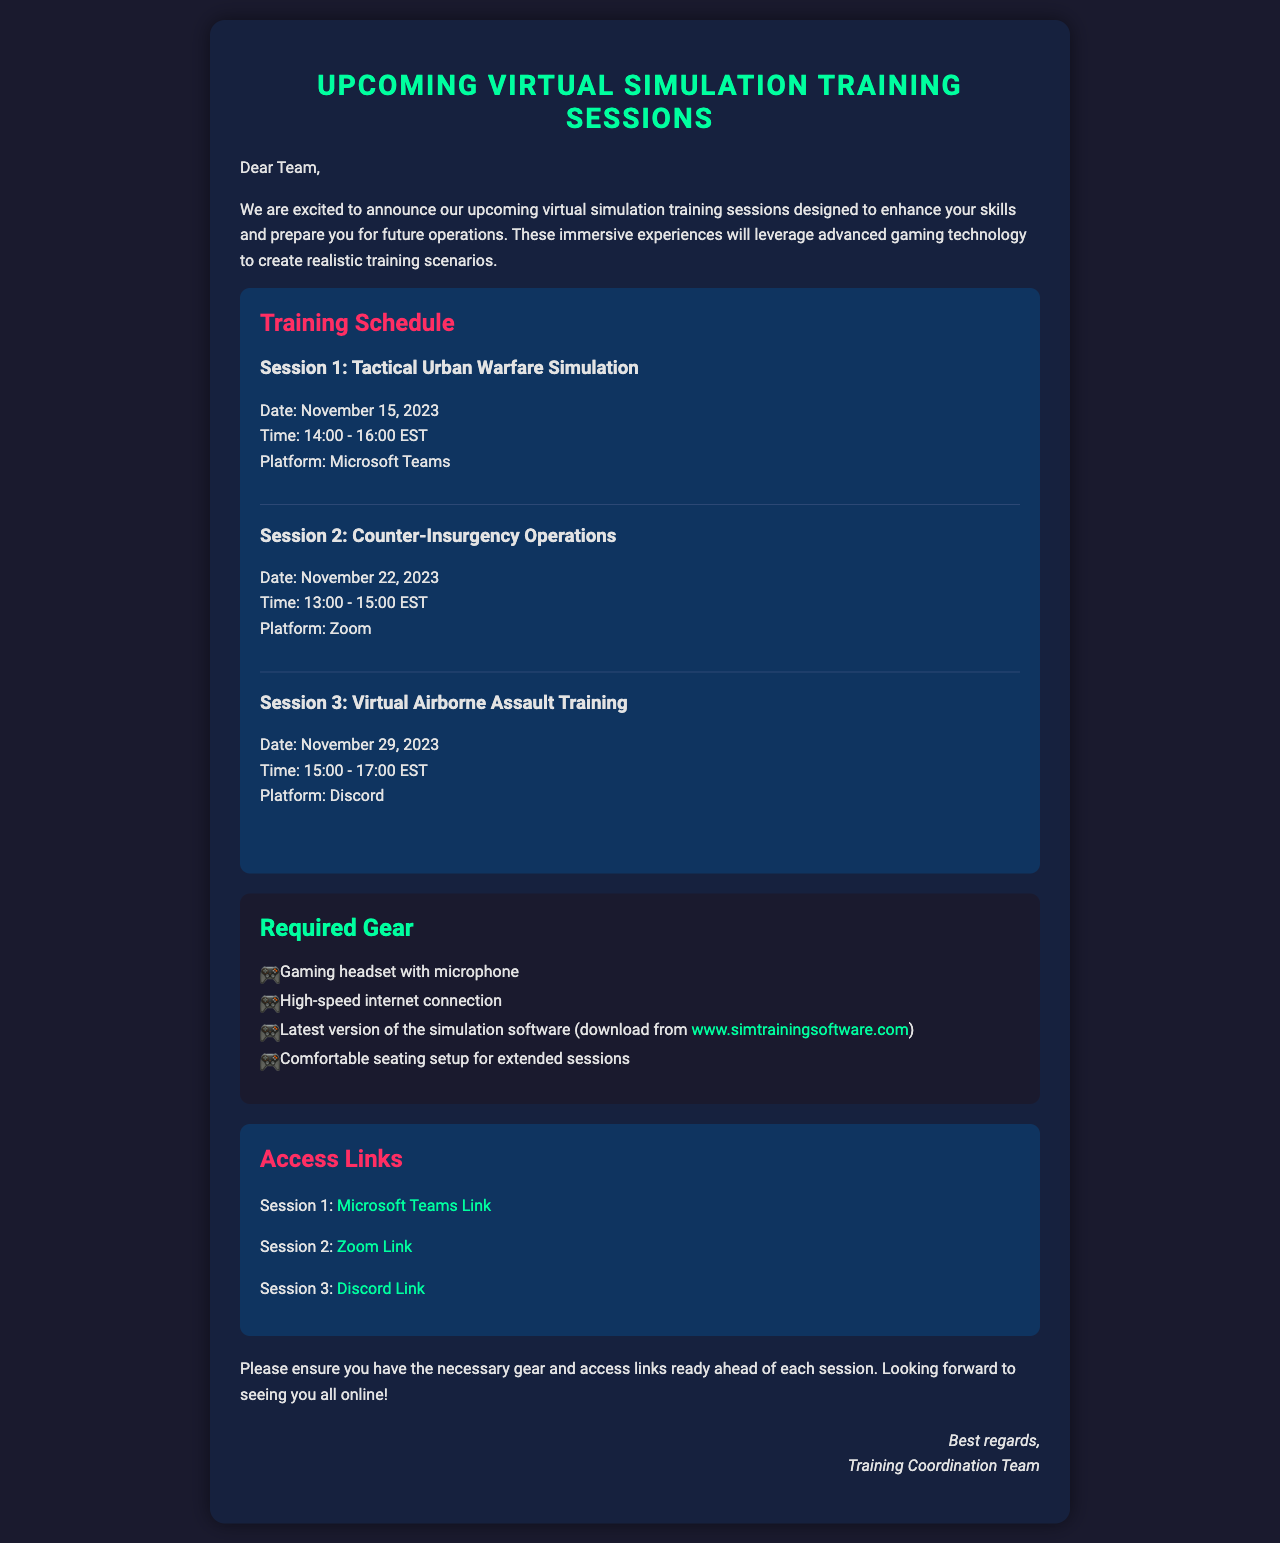What is the date of Session 1? The date for Session 1, which is the Tactical Urban Warfare Simulation, is provided in the schedule section of the document.
Answer: November 15, 2023 What platform will be used for Session 2? The platform for Session 2, which is for Counter-Insurgency Operations, is mentioned in the schedule section of the document.
Answer: Zoom What time does Session 3 start? The start time for Session 3, which is the Virtual Airborne Assault Training, is given in the schedule section of the document.
Answer: 15:00 What is one of the required gear items? The document lists several items required for participation in the training, detailed under the required gear section.
Answer: Gaming headset with microphone How many sessions are scheduled? By counting the sessions listed in the training schedule, we can determine the total number of sessions planned as described in the document.
Answer: 3 What link is provided for Session 1? The document specifies the Microsoft Teams link to join Session 1, which is provided in the access links section.
Answer: Microsoft Teams Link What is the duration of Session 2? The document states the start and end times for Session 2, allowing us to calculate its duration.
Answer: 2 hours What is the title of the second training session? The title of the second session, found in the schedule, allows us to provide this information directly.
Answer: Counter-Insurgency Operations 